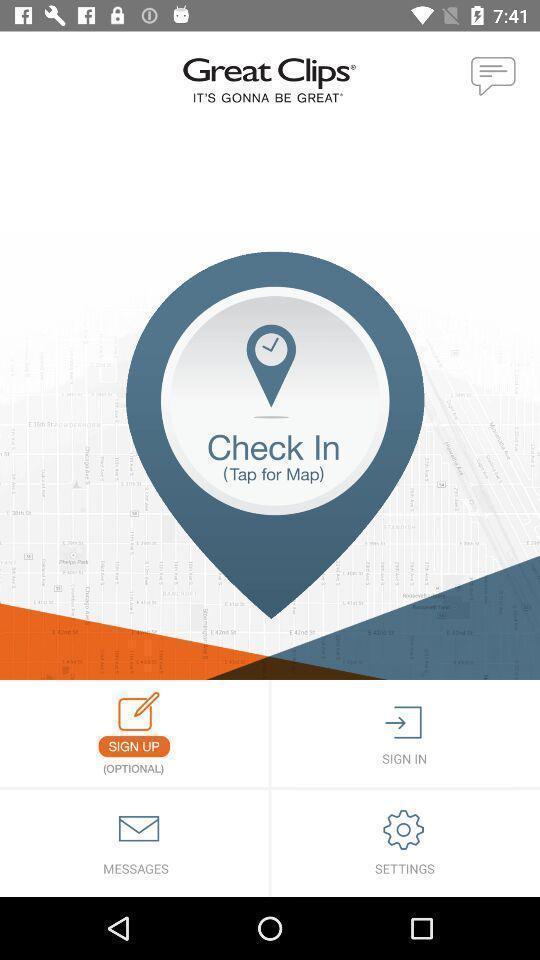Give me a narrative description of this picture. Sign up page with options in the location guide app. 